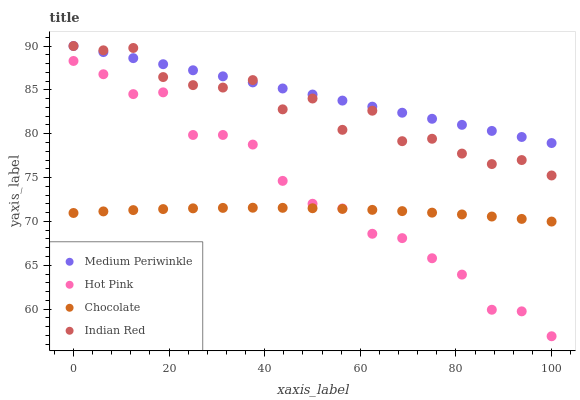Does Chocolate have the minimum area under the curve?
Answer yes or no. Yes. Does Medium Periwinkle have the maximum area under the curve?
Answer yes or no. Yes. Does Indian Red have the minimum area under the curve?
Answer yes or no. No. Does Indian Red have the maximum area under the curve?
Answer yes or no. No. Is Medium Periwinkle the smoothest?
Answer yes or no. Yes. Is Indian Red the roughest?
Answer yes or no. Yes. Is Indian Red the smoothest?
Answer yes or no. No. Is Medium Periwinkle the roughest?
Answer yes or no. No. Does Hot Pink have the lowest value?
Answer yes or no. Yes. Does Indian Red have the lowest value?
Answer yes or no. No. Does Indian Red have the highest value?
Answer yes or no. Yes. Does Chocolate have the highest value?
Answer yes or no. No. Is Chocolate less than Indian Red?
Answer yes or no. Yes. Is Medium Periwinkle greater than Chocolate?
Answer yes or no. Yes. Does Hot Pink intersect Chocolate?
Answer yes or no. Yes. Is Hot Pink less than Chocolate?
Answer yes or no. No. Is Hot Pink greater than Chocolate?
Answer yes or no. No. Does Chocolate intersect Indian Red?
Answer yes or no. No. 